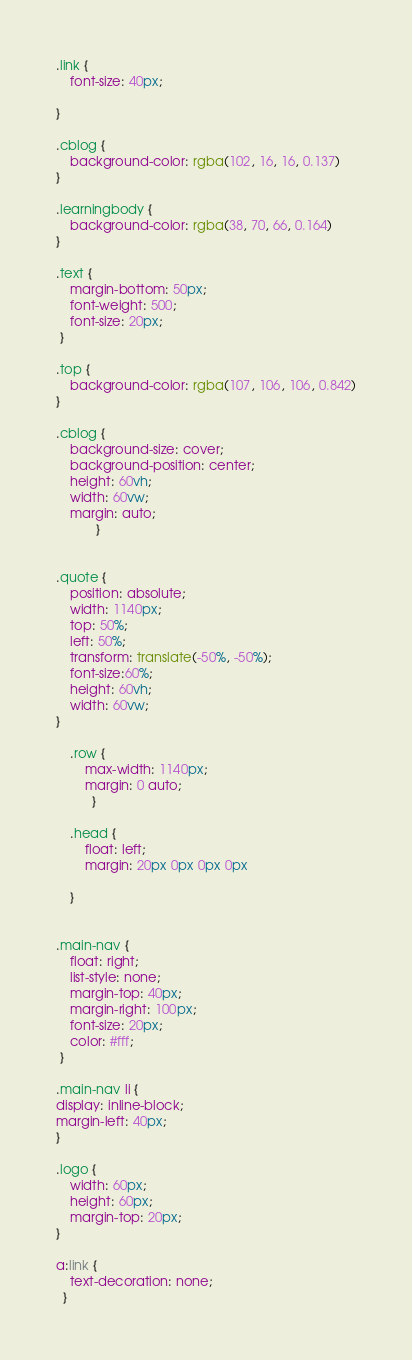<code> <loc_0><loc_0><loc_500><loc_500><_CSS_>.link {
    font-size: 40px;

}

.cblog {
    background-color: rgba(102, 16, 16, 0.137)
}

.learningbody {
    background-color: rgba(38, 70, 66, 0.164)
}

.text {
    margin-bottom: 50px;
    font-weight: 500;
    font-size: 20px;
 }

.top {
    background-color: rgba(107, 106, 106, 0.842)
}

.cblog {
    background-size: cover;
    background-position: center;
    height: 60vh; 
    width: 60vw;
    margin: auto;
           }


.quote {
    position: absolute;
    width: 1140px;
    top: 50%;
    left: 50%;
    transform: translate(-50%, -50%);
    font-size:60%;
    height: 60vh; 
    width: 60vw;
}

    .row {
        max-width: 1140px;
        margin: 0 auto;
          }

    .head {
        float: left;
        margin: 20px 0px 0px 0px
        
    }


.main-nav {
    float: right;
    list-style: none;
    margin-top: 40px;
    margin-right: 100px;
    font-size: 20px;
    color: #fff;
 }

.main-nav li {
display: inline-block;
margin-left: 40px;
}

.logo {
    width: 60px;
    height: 60px;
    margin-top: 20px;
}

a:link {
    text-decoration: none;
  }</code> 